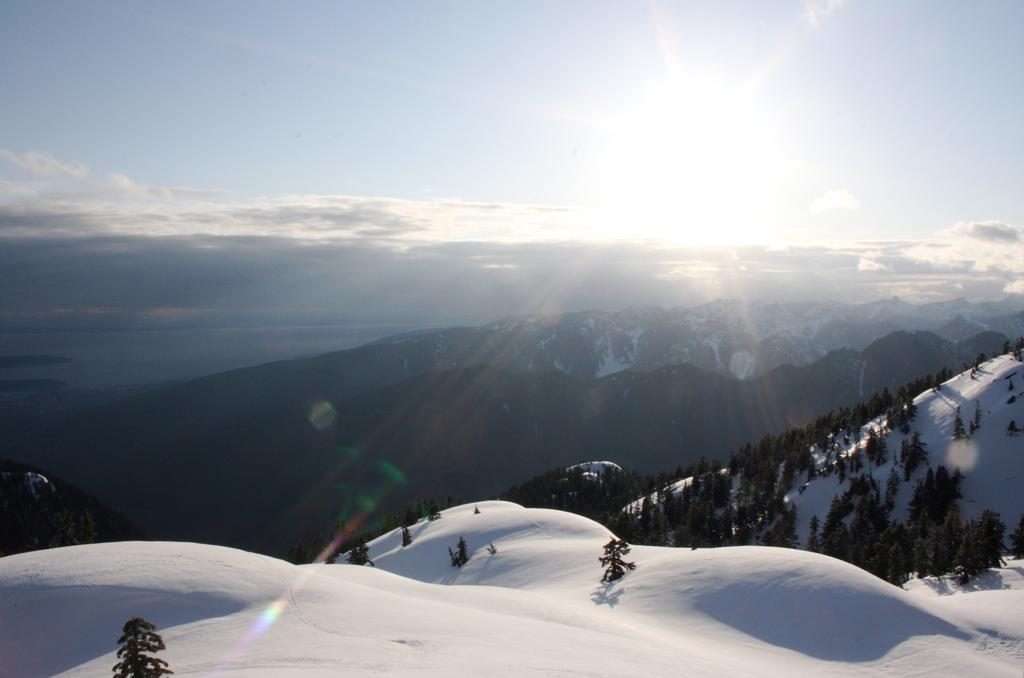What type of natural features can be seen in the image? There are trees and mountains visible in the image. What is the weather like in the image? There is snow visible in the image, which suggests a cold or wintery climate. What is visible in the background of the image? The sky is visible in the background of the image. What can be seen in the sky? Clouds are present in the sky. What type of club can be seen in the image? There is no club present in the image; it features natural elements such as trees, mountains, snow, sky, and clouds. 